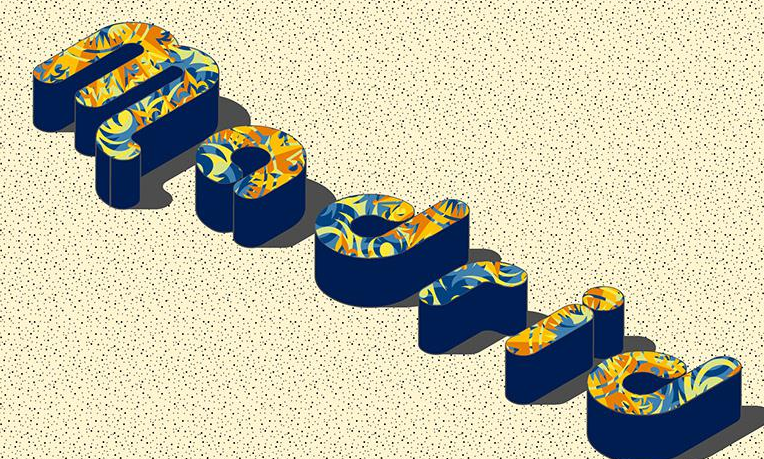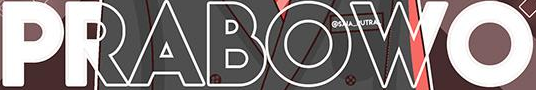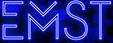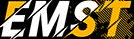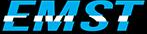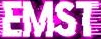What text appears in these images from left to right, separated by a semicolon? Madrid; PRABOWO; EMST; EMST; EMST; EMST 